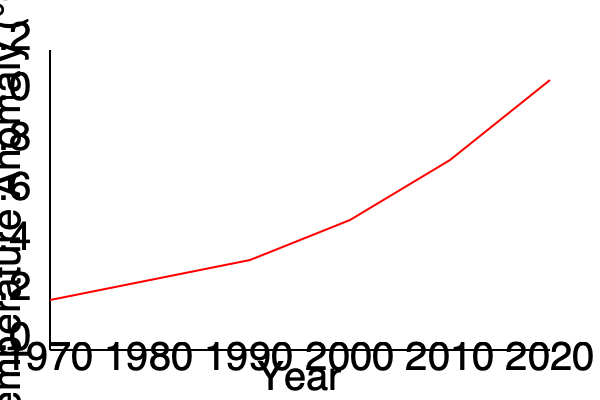Analyze the global temperature anomaly trend shown in the graph. Calculate the average rate of temperature increase per decade between 1970 and 2020, and discuss the potential implications for natural disaster frequency. To solve this problem, we'll follow these steps:

1. Determine the total temperature change:
   - 1970 temperature anomaly: approximately 0.2°C
   - 2020 temperature anomaly: approximately 1.1°C
   - Total change: 1.1°C - 0.2°C = 0.9°C

2. Calculate the rate of change per decade:
   - Time span: 2020 - 1970 = 50 years = 5 decades
   - Rate of change = Total change / Number of decades
   - Rate = 0.9°C / 5 = 0.18°C per decade

3. Implications for natural disaster frequency:
   - Increased global temperatures can lead to:
     a) More frequent and intense heatwaves
     b) Changes in precipitation patterns, potentially causing more droughts or floods
     c) Intensification of tropical cyclones
     d) Rising sea levels, increasing the risk of coastal flooding
     e) More frequent wildfires due to drier conditions in some regions

The average rate of temperature increase of 0.18°C per decade is significant and aligns with the observed increase in natural disaster frequency and intensity. This warming trend can destabilize weather patterns, leading to more extreme events. The relationship between temperature rise and disaster frequency is complex and varies by region, but the overall trend suggests an increased risk of climate-related disasters.
Answer: 0.18°C per decade; increased risk of more frequent and intense natural disasters 